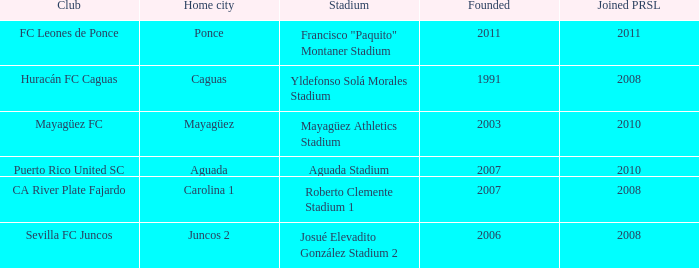What is the earliest founded when the home city is mayagüez? 2003.0. 